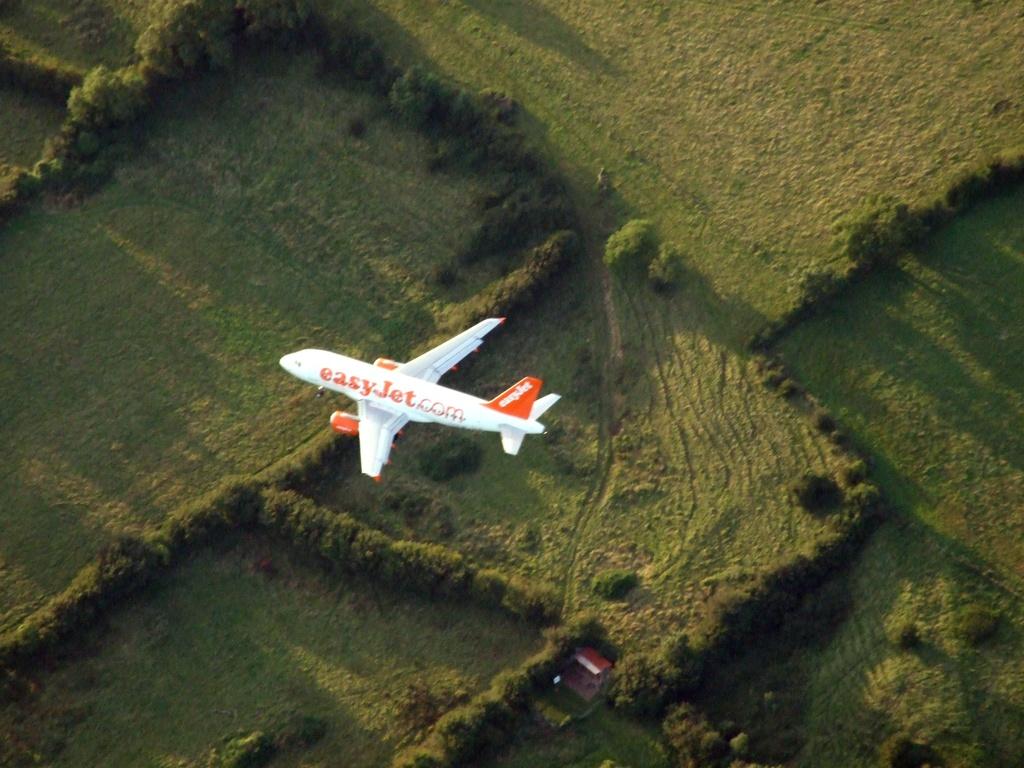Which airline is this?
Your answer should be very brief. Easy jet. What is this airline's web address?
Ensure brevity in your answer.  Easyjet.com. 